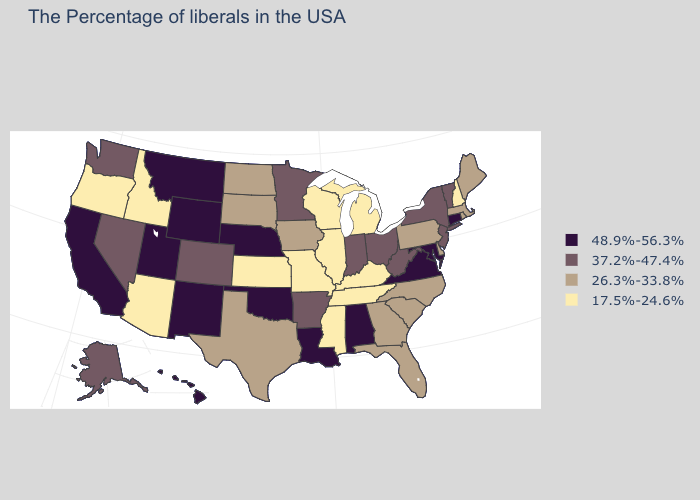What is the highest value in states that border Georgia?
Concise answer only. 48.9%-56.3%. Name the states that have a value in the range 17.5%-24.6%?
Answer briefly. New Hampshire, Michigan, Kentucky, Tennessee, Wisconsin, Illinois, Mississippi, Missouri, Kansas, Arizona, Idaho, Oregon. What is the highest value in the USA?
Write a very short answer. 48.9%-56.3%. Does the first symbol in the legend represent the smallest category?
Write a very short answer. No. Among the states that border New Hampshire , which have the highest value?
Keep it brief. Vermont. Name the states that have a value in the range 48.9%-56.3%?
Write a very short answer. Connecticut, Maryland, Virginia, Alabama, Louisiana, Nebraska, Oklahoma, Wyoming, New Mexico, Utah, Montana, California, Hawaii. Name the states that have a value in the range 37.2%-47.4%?
Short answer required. Vermont, New York, New Jersey, West Virginia, Ohio, Indiana, Arkansas, Minnesota, Colorado, Nevada, Washington, Alaska. Does the map have missing data?
Concise answer only. No. What is the highest value in states that border Florida?
Concise answer only. 48.9%-56.3%. What is the highest value in the USA?
Concise answer only. 48.9%-56.3%. Does Colorado have the lowest value in the West?
Be succinct. No. What is the value of Washington?
Keep it brief. 37.2%-47.4%. Does the map have missing data?
Short answer required. No. What is the value of Connecticut?
Concise answer only. 48.9%-56.3%. 